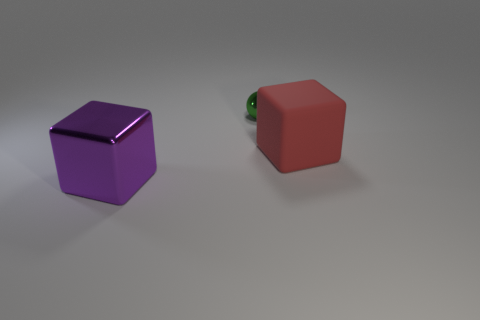Add 1 big objects. How many objects exist? 4 Subtract all red cubes. How many cubes are left? 1 Subtract 1 blocks. How many blocks are left? 1 Add 2 small red cylinders. How many small red cylinders exist? 2 Subtract 0 brown balls. How many objects are left? 3 Subtract all spheres. How many objects are left? 2 Subtract all cyan blocks. Subtract all cyan cylinders. How many blocks are left? 2 Subtract all purple cylinders. How many red blocks are left? 1 Subtract all big red metallic objects. Subtract all big cubes. How many objects are left? 1 Add 2 balls. How many balls are left? 3 